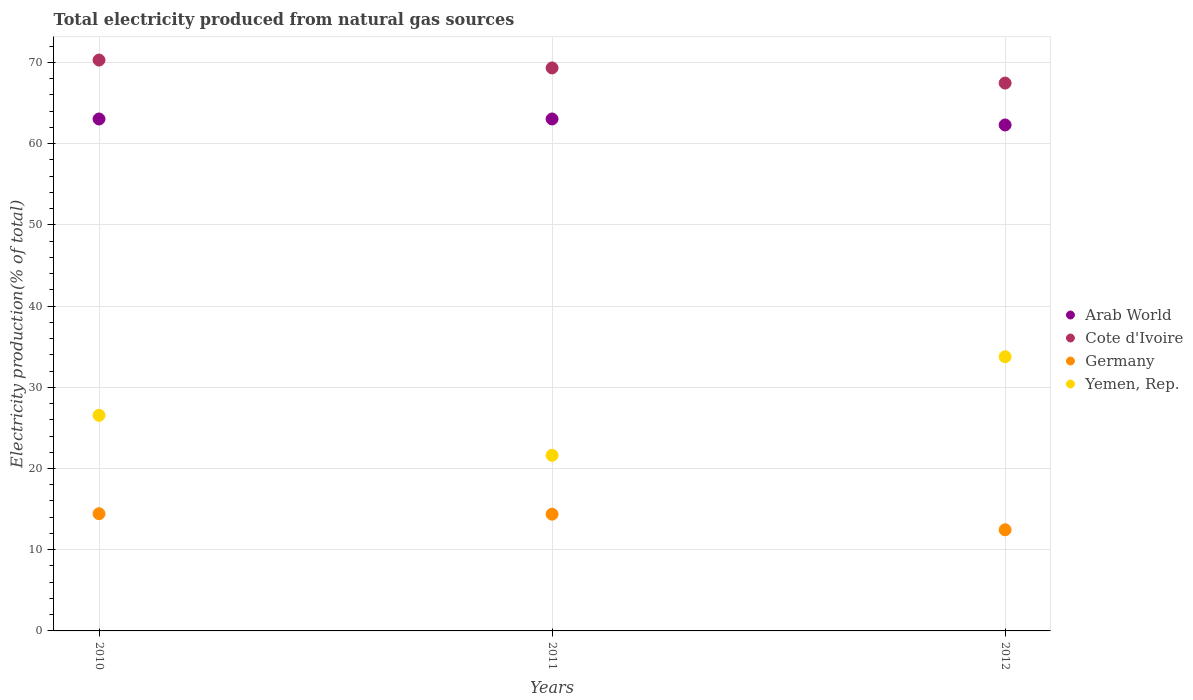Is the number of dotlines equal to the number of legend labels?
Ensure brevity in your answer.  Yes. What is the total electricity produced in Arab World in 2010?
Ensure brevity in your answer.  63.04. Across all years, what is the maximum total electricity produced in Yemen, Rep.?
Offer a very short reply. 33.76. Across all years, what is the minimum total electricity produced in Yemen, Rep.?
Your answer should be compact. 21.62. In which year was the total electricity produced in Arab World minimum?
Give a very brief answer. 2012. What is the total total electricity produced in Germany in the graph?
Provide a succinct answer. 41.26. What is the difference between the total electricity produced in Germany in 2010 and that in 2011?
Provide a short and direct response. 0.06. What is the difference between the total electricity produced in Cote d'Ivoire in 2012 and the total electricity produced in Arab World in 2010?
Offer a terse response. 4.42. What is the average total electricity produced in Arab World per year?
Your response must be concise. 62.79. In the year 2011, what is the difference between the total electricity produced in Cote d'Ivoire and total electricity produced in Arab World?
Make the answer very short. 6.28. What is the ratio of the total electricity produced in Yemen, Rep. in 2010 to that in 2012?
Your answer should be compact. 0.79. Is the total electricity produced in Arab World in 2010 less than that in 2012?
Your answer should be very brief. No. What is the difference between the highest and the second highest total electricity produced in Arab World?
Provide a succinct answer. 0. What is the difference between the highest and the lowest total electricity produced in Yemen, Rep.?
Provide a short and direct response. 12.13. In how many years, is the total electricity produced in Cote d'Ivoire greater than the average total electricity produced in Cote d'Ivoire taken over all years?
Give a very brief answer. 2. Is the sum of the total electricity produced in Yemen, Rep. in 2010 and 2012 greater than the maximum total electricity produced in Arab World across all years?
Provide a succinct answer. No. Is it the case that in every year, the sum of the total electricity produced in Arab World and total electricity produced in Germany  is greater than the sum of total electricity produced in Cote d'Ivoire and total electricity produced in Yemen, Rep.?
Your answer should be compact. No. Does the total electricity produced in Cote d'Ivoire monotonically increase over the years?
Your answer should be very brief. No. Is the total electricity produced in Cote d'Ivoire strictly greater than the total electricity produced in Germany over the years?
Your answer should be very brief. Yes. How many dotlines are there?
Your answer should be very brief. 4. Does the graph contain grids?
Provide a succinct answer. Yes. Where does the legend appear in the graph?
Ensure brevity in your answer.  Center right. How many legend labels are there?
Your response must be concise. 4. How are the legend labels stacked?
Provide a succinct answer. Vertical. What is the title of the graph?
Offer a terse response. Total electricity produced from natural gas sources. What is the label or title of the X-axis?
Ensure brevity in your answer.  Years. What is the Electricity production(% of total) of Arab World in 2010?
Your response must be concise. 63.04. What is the Electricity production(% of total) of Cote d'Ivoire in 2010?
Your answer should be compact. 70.29. What is the Electricity production(% of total) of Germany in 2010?
Make the answer very short. 14.43. What is the Electricity production(% of total) of Yemen, Rep. in 2010?
Your answer should be compact. 26.55. What is the Electricity production(% of total) of Arab World in 2011?
Provide a succinct answer. 63.04. What is the Electricity production(% of total) in Cote d'Ivoire in 2011?
Keep it short and to the point. 69.32. What is the Electricity production(% of total) of Germany in 2011?
Make the answer very short. 14.37. What is the Electricity production(% of total) in Yemen, Rep. in 2011?
Offer a terse response. 21.62. What is the Electricity production(% of total) of Arab World in 2012?
Your response must be concise. 62.3. What is the Electricity production(% of total) in Cote d'Ivoire in 2012?
Keep it short and to the point. 67.46. What is the Electricity production(% of total) in Germany in 2012?
Ensure brevity in your answer.  12.45. What is the Electricity production(% of total) in Yemen, Rep. in 2012?
Ensure brevity in your answer.  33.76. Across all years, what is the maximum Electricity production(% of total) in Arab World?
Give a very brief answer. 63.04. Across all years, what is the maximum Electricity production(% of total) in Cote d'Ivoire?
Provide a succinct answer. 70.29. Across all years, what is the maximum Electricity production(% of total) of Germany?
Your response must be concise. 14.43. Across all years, what is the maximum Electricity production(% of total) in Yemen, Rep.?
Your answer should be compact. 33.76. Across all years, what is the minimum Electricity production(% of total) of Arab World?
Keep it short and to the point. 62.3. Across all years, what is the minimum Electricity production(% of total) in Cote d'Ivoire?
Ensure brevity in your answer.  67.46. Across all years, what is the minimum Electricity production(% of total) in Germany?
Make the answer very short. 12.45. Across all years, what is the minimum Electricity production(% of total) in Yemen, Rep.?
Ensure brevity in your answer.  21.62. What is the total Electricity production(% of total) of Arab World in the graph?
Your answer should be very brief. 188.38. What is the total Electricity production(% of total) of Cote d'Ivoire in the graph?
Give a very brief answer. 207.08. What is the total Electricity production(% of total) in Germany in the graph?
Make the answer very short. 41.26. What is the total Electricity production(% of total) in Yemen, Rep. in the graph?
Your response must be concise. 81.93. What is the difference between the Electricity production(% of total) of Arab World in 2010 and that in 2011?
Ensure brevity in your answer.  -0. What is the difference between the Electricity production(% of total) in Cote d'Ivoire in 2010 and that in 2011?
Give a very brief answer. 0.97. What is the difference between the Electricity production(% of total) of Germany in 2010 and that in 2011?
Give a very brief answer. 0.06. What is the difference between the Electricity production(% of total) of Yemen, Rep. in 2010 and that in 2011?
Your answer should be compact. 4.93. What is the difference between the Electricity production(% of total) in Arab World in 2010 and that in 2012?
Provide a succinct answer. 0.73. What is the difference between the Electricity production(% of total) of Cote d'Ivoire in 2010 and that in 2012?
Your answer should be very brief. 2.83. What is the difference between the Electricity production(% of total) in Germany in 2010 and that in 2012?
Give a very brief answer. 1.98. What is the difference between the Electricity production(% of total) in Yemen, Rep. in 2010 and that in 2012?
Your answer should be very brief. -7.21. What is the difference between the Electricity production(% of total) in Arab World in 2011 and that in 2012?
Offer a very short reply. 0.74. What is the difference between the Electricity production(% of total) of Cote d'Ivoire in 2011 and that in 2012?
Provide a succinct answer. 1.86. What is the difference between the Electricity production(% of total) of Germany in 2011 and that in 2012?
Offer a very short reply. 1.92. What is the difference between the Electricity production(% of total) in Yemen, Rep. in 2011 and that in 2012?
Keep it short and to the point. -12.13. What is the difference between the Electricity production(% of total) in Arab World in 2010 and the Electricity production(% of total) in Cote d'Ivoire in 2011?
Ensure brevity in your answer.  -6.29. What is the difference between the Electricity production(% of total) of Arab World in 2010 and the Electricity production(% of total) of Germany in 2011?
Ensure brevity in your answer.  48.66. What is the difference between the Electricity production(% of total) in Arab World in 2010 and the Electricity production(% of total) in Yemen, Rep. in 2011?
Keep it short and to the point. 41.41. What is the difference between the Electricity production(% of total) in Cote d'Ivoire in 2010 and the Electricity production(% of total) in Germany in 2011?
Your answer should be compact. 55.92. What is the difference between the Electricity production(% of total) of Cote d'Ivoire in 2010 and the Electricity production(% of total) of Yemen, Rep. in 2011?
Keep it short and to the point. 48.67. What is the difference between the Electricity production(% of total) of Germany in 2010 and the Electricity production(% of total) of Yemen, Rep. in 2011?
Provide a short and direct response. -7.19. What is the difference between the Electricity production(% of total) of Arab World in 2010 and the Electricity production(% of total) of Cote d'Ivoire in 2012?
Your response must be concise. -4.42. What is the difference between the Electricity production(% of total) of Arab World in 2010 and the Electricity production(% of total) of Germany in 2012?
Provide a short and direct response. 50.58. What is the difference between the Electricity production(% of total) in Arab World in 2010 and the Electricity production(% of total) in Yemen, Rep. in 2012?
Your answer should be very brief. 29.28. What is the difference between the Electricity production(% of total) of Cote d'Ivoire in 2010 and the Electricity production(% of total) of Germany in 2012?
Your answer should be very brief. 57.84. What is the difference between the Electricity production(% of total) in Cote d'Ivoire in 2010 and the Electricity production(% of total) in Yemen, Rep. in 2012?
Your response must be concise. 36.53. What is the difference between the Electricity production(% of total) in Germany in 2010 and the Electricity production(% of total) in Yemen, Rep. in 2012?
Make the answer very short. -19.33. What is the difference between the Electricity production(% of total) of Arab World in 2011 and the Electricity production(% of total) of Cote d'Ivoire in 2012?
Offer a very short reply. -4.42. What is the difference between the Electricity production(% of total) of Arab World in 2011 and the Electricity production(% of total) of Germany in 2012?
Offer a terse response. 50.59. What is the difference between the Electricity production(% of total) of Arab World in 2011 and the Electricity production(% of total) of Yemen, Rep. in 2012?
Offer a very short reply. 29.28. What is the difference between the Electricity production(% of total) in Cote d'Ivoire in 2011 and the Electricity production(% of total) in Germany in 2012?
Your answer should be very brief. 56.87. What is the difference between the Electricity production(% of total) of Cote d'Ivoire in 2011 and the Electricity production(% of total) of Yemen, Rep. in 2012?
Offer a very short reply. 35.56. What is the difference between the Electricity production(% of total) in Germany in 2011 and the Electricity production(% of total) in Yemen, Rep. in 2012?
Keep it short and to the point. -19.38. What is the average Electricity production(% of total) of Arab World per year?
Your answer should be very brief. 62.79. What is the average Electricity production(% of total) of Cote d'Ivoire per year?
Ensure brevity in your answer.  69.03. What is the average Electricity production(% of total) of Germany per year?
Provide a succinct answer. 13.75. What is the average Electricity production(% of total) in Yemen, Rep. per year?
Offer a terse response. 27.31. In the year 2010, what is the difference between the Electricity production(% of total) of Arab World and Electricity production(% of total) of Cote d'Ivoire?
Keep it short and to the point. -7.26. In the year 2010, what is the difference between the Electricity production(% of total) of Arab World and Electricity production(% of total) of Germany?
Provide a short and direct response. 48.6. In the year 2010, what is the difference between the Electricity production(% of total) in Arab World and Electricity production(% of total) in Yemen, Rep.?
Give a very brief answer. 36.49. In the year 2010, what is the difference between the Electricity production(% of total) in Cote d'Ivoire and Electricity production(% of total) in Germany?
Keep it short and to the point. 55.86. In the year 2010, what is the difference between the Electricity production(% of total) in Cote d'Ivoire and Electricity production(% of total) in Yemen, Rep.?
Offer a very short reply. 43.74. In the year 2010, what is the difference between the Electricity production(% of total) of Germany and Electricity production(% of total) of Yemen, Rep.?
Make the answer very short. -12.12. In the year 2011, what is the difference between the Electricity production(% of total) in Arab World and Electricity production(% of total) in Cote d'Ivoire?
Ensure brevity in your answer.  -6.28. In the year 2011, what is the difference between the Electricity production(% of total) of Arab World and Electricity production(% of total) of Germany?
Your answer should be very brief. 48.66. In the year 2011, what is the difference between the Electricity production(% of total) in Arab World and Electricity production(% of total) in Yemen, Rep.?
Provide a short and direct response. 41.41. In the year 2011, what is the difference between the Electricity production(% of total) of Cote d'Ivoire and Electricity production(% of total) of Germany?
Your response must be concise. 54.95. In the year 2011, what is the difference between the Electricity production(% of total) of Cote d'Ivoire and Electricity production(% of total) of Yemen, Rep.?
Keep it short and to the point. 47.7. In the year 2011, what is the difference between the Electricity production(% of total) in Germany and Electricity production(% of total) in Yemen, Rep.?
Offer a very short reply. -7.25. In the year 2012, what is the difference between the Electricity production(% of total) of Arab World and Electricity production(% of total) of Cote d'Ivoire?
Provide a short and direct response. -5.16. In the year 2012, what is the difference between the Electricity production(% of total) in Arab World and Electricity production(% of total) in Germany?
Your response must be concise. 49.85. In the year 2012, what is the difference between the Electricity production(% of total) of Arab World and Electricity production(% of total) of Yemen, Rep.?
Your response must be concise. 28.54. In the year 2012, what is the difference between the Electricity production(% of total) of Cote d'Ivoire and Electricity production(% of total) of Germany?
Your response must be concise. 55.01. In the year 2012, what is the difference between the Electricity production(% of total) in Cote d'Ivoire and Electricity production(% of total) in Yemen, Rep.?
Your answer should be compact. 33.7. In the year 2012, what is the difference between the Electricity production(% of total) in Germany and Electricity production(% of total) in Yemen, Rep.?
Your answer should be compact. -21.31. What is the ratio of the Electricity production(% of total) in Arab World in 2010 to that in 2011?
Offer a terse response. 1. What is the ratio of the Electricity production(% of total) in Cote d'Ivoire in 2010 to that in 2011?
Make the answer very short. 1.01. What is the ratio of the Electricity production(% of total) of Yemen, Rep. in 2010 to that in 2011?
Offer a very short reply. 1.23. What is the ratio of the Electricity production(% of total) in Arab World in 2010 to that in 2012?
Make the answer very short. 1.01. What is the ratio of the Electricity production(% of total) in Cote d'Ivoire in 2010 to that in 2012?
Offer a very short reply. 1.04. What is the ratio of the Electricity production(% of total) in Germany in 2010 to that in 2012?
Make the answer very short. 1.16. What is the ratio of the Electricity production(% of total) of Yemen, Rep. in 2010 to that in 2012?
Give a very brief answer. 0.79. What is the ratio of the Electricity production(% of total) in Arab World in 2011 to that in 2012?
Your answer should be very brief. 1.01. What is the ratio of the Electricity production(% of total) in Cote d'Ivoire in 2011 to that in 2012?
Ensure brevity in your answer.  1.03. What is the ratio of the Electricity production(% of total) in Germany in 2011 to that in 2012?
Offer a terse response. 1.15. What is the ratio of the Electricity production(% of total) of Yemen, Rep. in 2011 to that in 2012?
Ensure brevity in your answer.  0.64. What is the difference between the highest and the second highest Electricity production(% of total) in Arab World?
Give a very brief answer. 0. What is the difference between the highest and the second highest Electricity production(% of total) in Cote d'Ivoire?
Give a very brief answer. 0.97. What is the difference between the highest and the second highest Electricity production(% of total) of Germany?
Make the answer very short. 0.06. What is the difference between the highest and the second highest Electricity production(% of total) of Yemen, Rep.?
Provide a short and direct response. 7.21. What is the difference between the highest and the lowest Electricity production(% of total) in Arab World?
Your response must be concise. 0.74. What is the difference between the highest and the lowest Electricity production(% of total) in Cote d'Ivoire?
Your answer should be compact. 2.83. What is the difference between the highest and the lowest Electricity production(% of total) in Germany?
Keep it short and to the point. 1.98. What is the difference between the highest and the lowest Electricity production(% of total) of Yemen, Rep.?
Offer a very short reply. 12.13. 